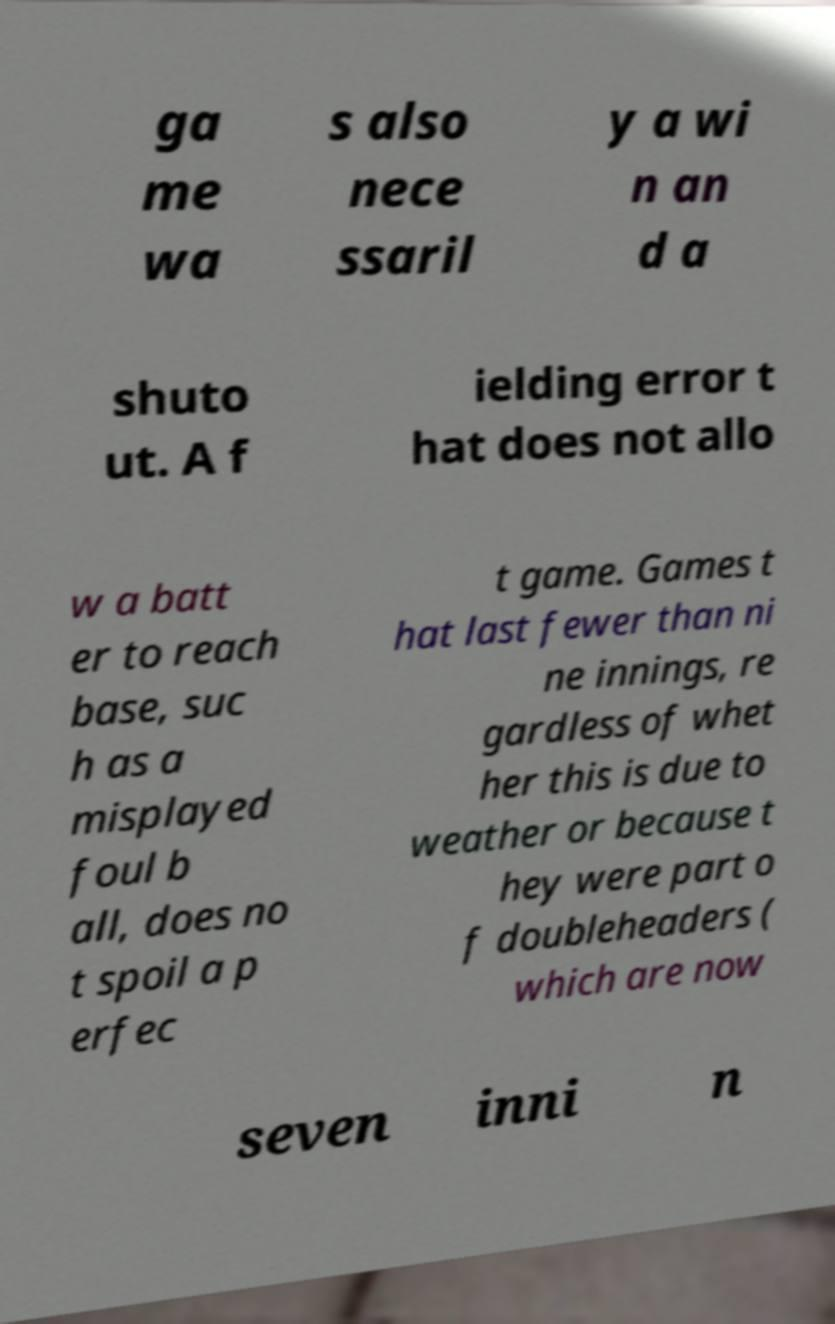Could you assist in decoding the text presented in this image and type it out clearly? ga me wa s also nece ssaril y a wi n an d a shuto ut. A f ielding error t hat does not allo w a batt er to reach base, suc h as a misplayed foul b all, does no t spoil a p erfec t game. Games t hat last fewer than ni ne innings, re gardless of whet her this is due to weather or because t hey were part o f doubleheaders ( which are now seven inni n 